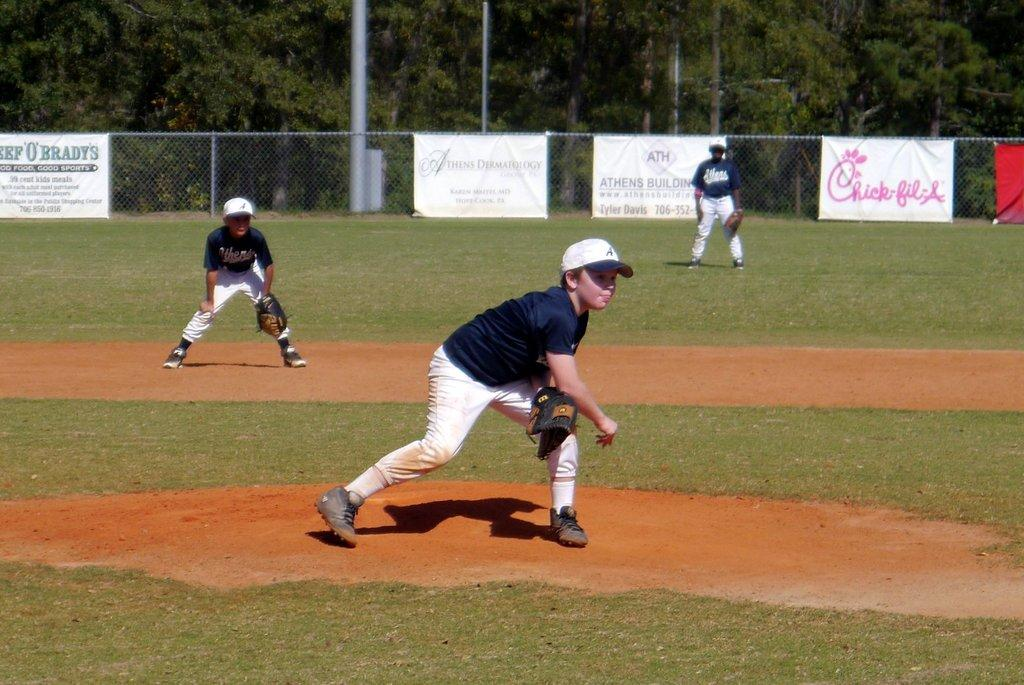<image>
Give a short and clear explanation of the subsequent image. A little league pitcher has just thrown a pitch, in the background is a sign for Chick-fil-A. 